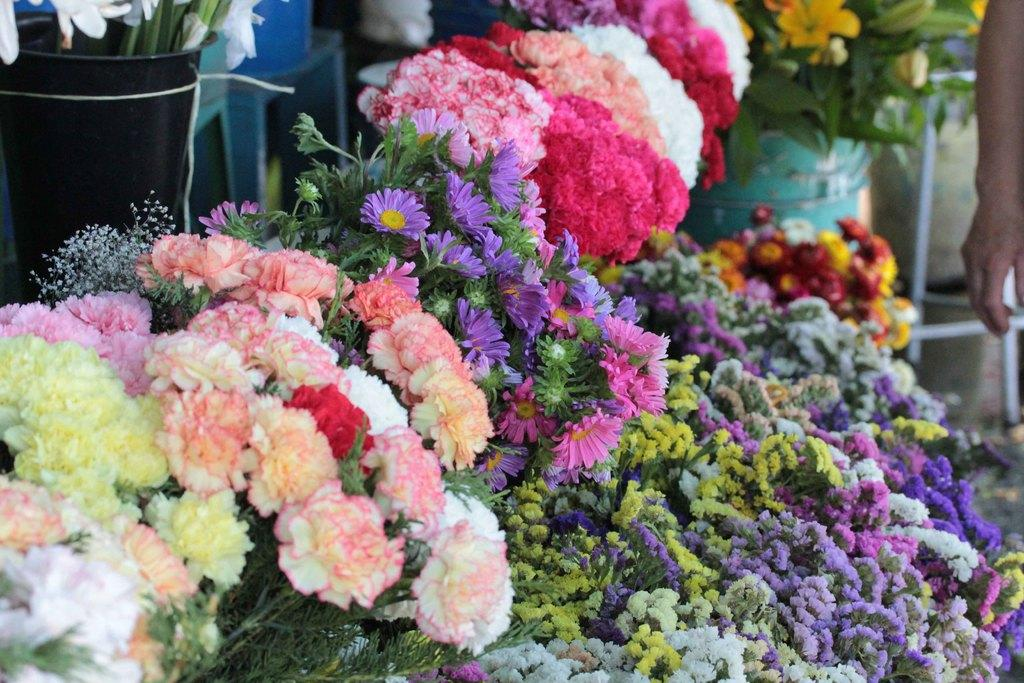What types of plants are visible in the image? There are different types of flowers in the image. Can you describe the person on the right side of the image? There is a person on the right side of the image, but no specific details about their appearance or actions are provided. What is located at the back of the image? There is a stand at the back of the image. What type of heart disease is the person on the right side of the image suffering from? There is no information about the person's health or any heart disease in the image. How many ants can be seen crawling on the flowers in the image? There are no ants visible in the image; it only features flowers and a person. 